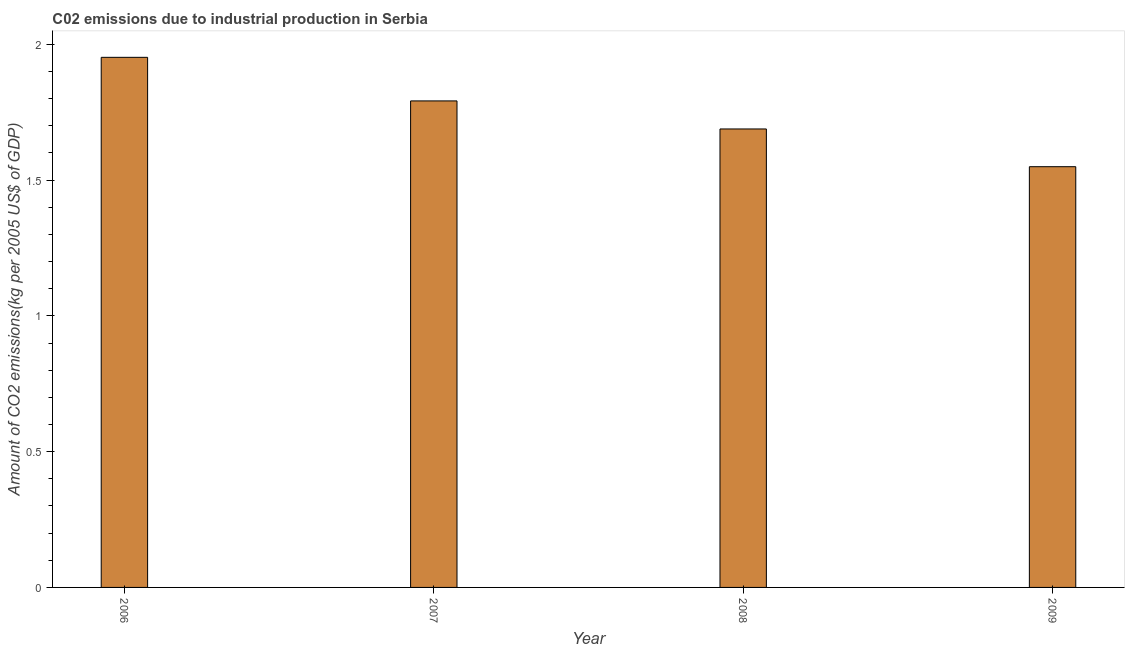Does the graph contain any zero values?
Your response must be concise. No. What is the title of the graph?
Your response must be concise. C02 emissions due to industrial production in Serbia. What is the label or title of the Y-axis?
Give a very brief answer. Amount of CO2 emissions(kg per 2005 US$ of GDP). What is the amount of co2 emissions in 2007?
Ensure brevity in your answer.  1.79. Across all years, what is the maximum amount of co2 emissions?
Ensure brevity in your answer.  1.95. Across all years, what is the minimum amount of co2 emissions?
Your response must be concise. 1.55. In which year was the amount of co2 emissions minimum?
Offer a terse response. 2009. What is the sum of the amount of co2 emissions?
Keep it short and to the point. 6.98. What is the difference between the amount of co2 emissions in 2007 and 2008?
Your response must be concise. 0.1. What is the average amount of co2 emissions per year?
Offer a terse response. 1.75. What is the median amount of co2 emissions?
Offer a very short reply. 1.74. Do a majority of the years between 2009 and 2007 (inclusive) have amount of co2 emissions greater than 0.4 kg per 2005 US$ of GDP?
Provide a succinct answer. Yes. What is the ratio of the amount of co2 emissions in 2006 to that in 2008?
Provide a succinct answer. 1.16. Is the amount of co2 emissions in 2006 less than that in 2008?
Your answer should be very brief. No. What is the difference between the highest and the second highest amount of co2 emissions?
Make the answer very short. 0.16. Is the sum of the amount of co2 emissions in 2006 and 2008 greater than the maximum amount of co2 emissions across all years?
Your answer should be very brief. Yes. In how many years, is the amount of co2 emissions greater than the average amount of co2 emissions taken over all years?
Ensure brevity in your answer.  2. How many bars are there?
Your answer should be compact. 4. Are all the bars in the graph horizontal?
Keep it short and to the point. No. How many years are there in the graph?
Offer a terse response. 4. What is the difference between two consecutive major ticks on the Y-axis?
Make the answer very short. 0.5. What is the Amount of CO2 emissions(kg per 2005 US$ of GDP) in 2006?
Your answer should be very brief. 1.95. What is the Amount of CO2 emissions(kg per 2005 US$ of GDP) of 2007?
Make the answer very short. 1.79. What is the Amount of CO2 emissions(kg per 2005 US$ of GDP) of 2008?
Your answer should be very brief. 1.69. What is the Amount of CO2 emissions(kg per 2005 US$ of GDP) in 2009?
Keep it short and to the point. 1.55. What is the difference between the Amount of CO2 emissions(kg per 2005 US$ of GDP) in 2006 and 2007?
Ensure brevity in your answer.  0.16. What is the difference between the Amount of CO2 emissions(kg per 2005 US$ of GDP) in 2006 and 2008?
Offer a very short reply. 0.26. What is the difference between the Amount of CO2 emissions(kg per 2005 US$ of GDP) in 2006 and 2009?
Offer a terse response. 0.4. What is the difference between the Amount of CO2 emissions(kg per 2005 US$ of GDP) in 2007 and 2008?
Your response must be concise. 0.1. What is the difference between the Amount of CO2 emissions(kg per 2005 US$ of GDP) in 2007 and 2009?
Your answer should be very brief. 0.24. What is the difference between the Amount of CO2 emissions(kg per 2005 US$ of GDP) in 2008 and 2009?
Keep it short and to the point. 0.14. What is the ratio of the Amount of CO2 emissions(kg per 2005 US$ of GDP) in 2006 to that in 2007?
Ensure brevity in your answer.  1.09. What is the ratio of the Amount of CO2 emissions(kg per 2005 US$ of GDP) in 2006 to that in 2008?
Provide a succinct answer. 1.16. What is the ratio of the Amount of CO2 emissions(kg per 2005 US$ of GDP) in 2006 to that in 2009?
Provide a short and direct response. 1.26. What is the ratio of the Amount of CO2 emissions(kg per 2005 US$ of GDP) in 2007 to that in 2008?
Make the answer very short. 1.06. What is the ratio of the Amount of CO2 emissions(kg per 2005 US$ of GDP) in 2007 to that in 2009?
Provide a succinct answer. 1.16. What is the ratio of the Amount of CO2 emissions(kg per 2005 US$ of GDP) in 2008 to that in 2009?
Offer a terse response. 1.09. 